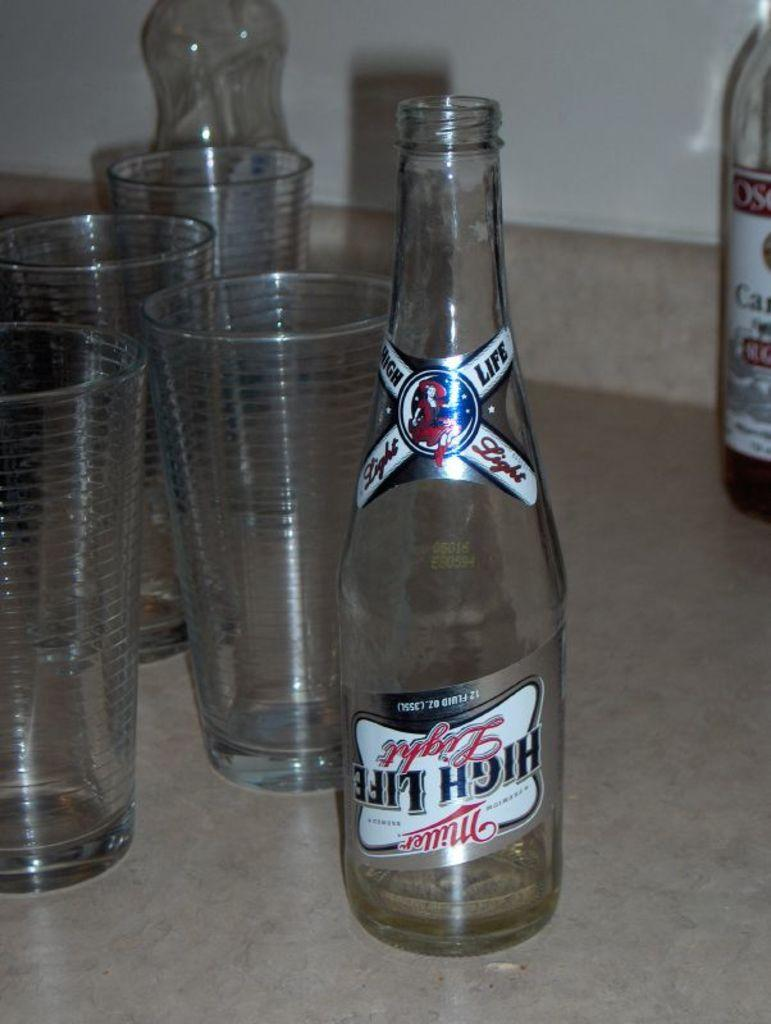<image>
Describe the image concisely. A bottle of Miller High Life that has an upside down label. 